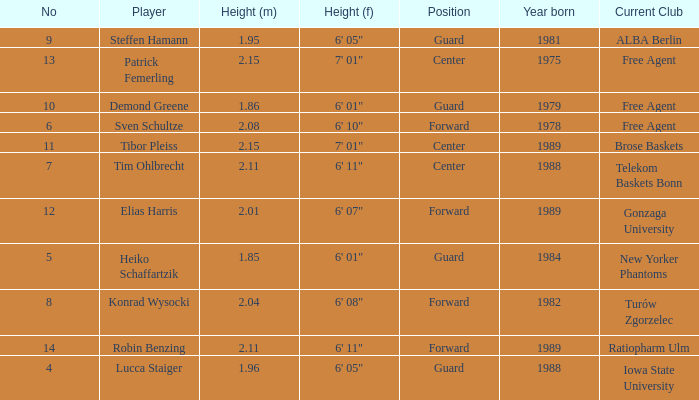Name the height of demond greene 6' 01". 